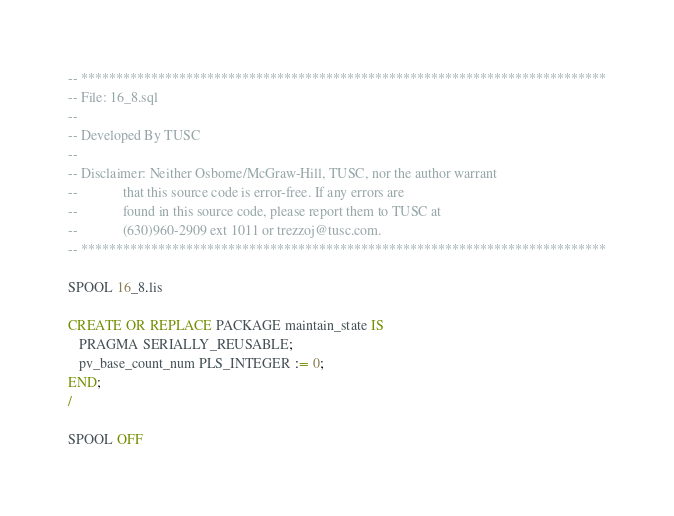<code> <loc_0><loc_0><loc_500><loc_500><_SQL_>-- ***************************************************************************
-- File: 16_8.sql
--
-- Developed By TUSC
--
-- Disclaimer: Neither Osborne/McGraw-Hill, TUSC, nor the author warrant
--             that this source code is error-free. If any errors are
--             found in this source code, please report them to TUSC at
--             (630)960-2909 ext 1011 or trezzoj@tusc.com.
-- ***************************************************************************

SPOOL 16_8.lis

CREATE OR REPLACE PACKAGE maintain_state IS
   PRAGMA SERIALLY_REUSABLE;
   pv_base_count_num PLS_INTEGER := 0;
END;
/

SPOOL OFF
</code> 